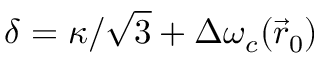Convert formula to latex. <formula><loc_0><loc_0><loc_500><loc_500>\delta = \kappa / \sqrt { 3 } + \Delta \omega _ { c } ( \vec { r } _ { 0 } )</formula> 